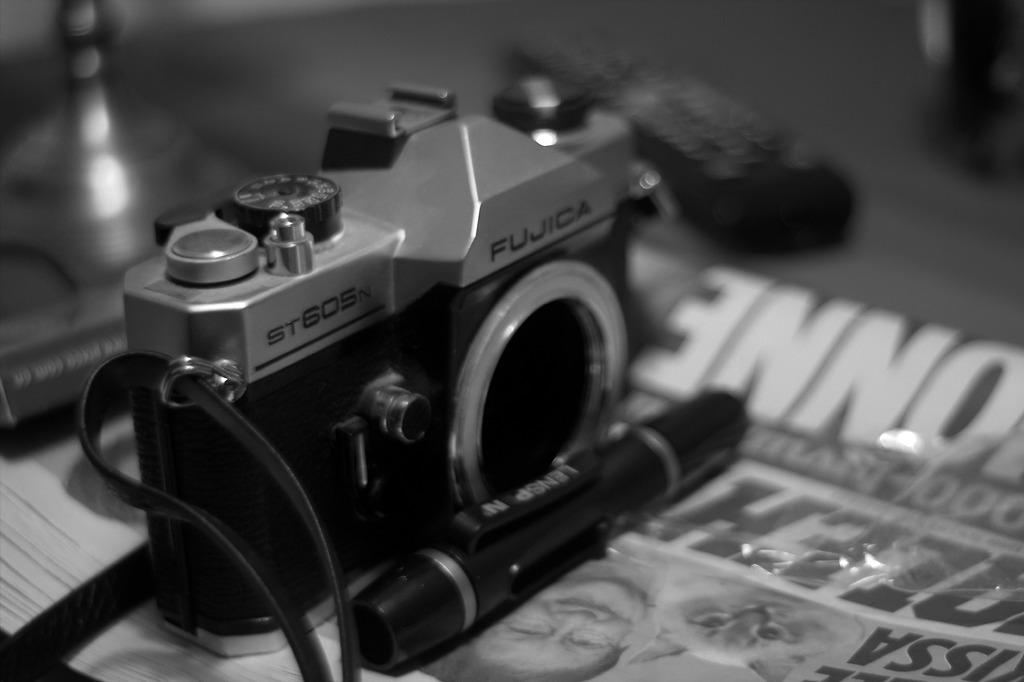What is the main object in the image? There is a camera in the image. What other object can be seen with the camera? There is a pen in the image. Where are the camera and pen placed? The camera and pen are on a newspaper. What is located on the left side of the image? There is a book on the left side of the image. How would you describe the background of the image? The background of the image is blurry. What type of poison is being used to clean the camera in the image? There is no poison present in the image, nor is there any indication that the camera is being cleaned. 